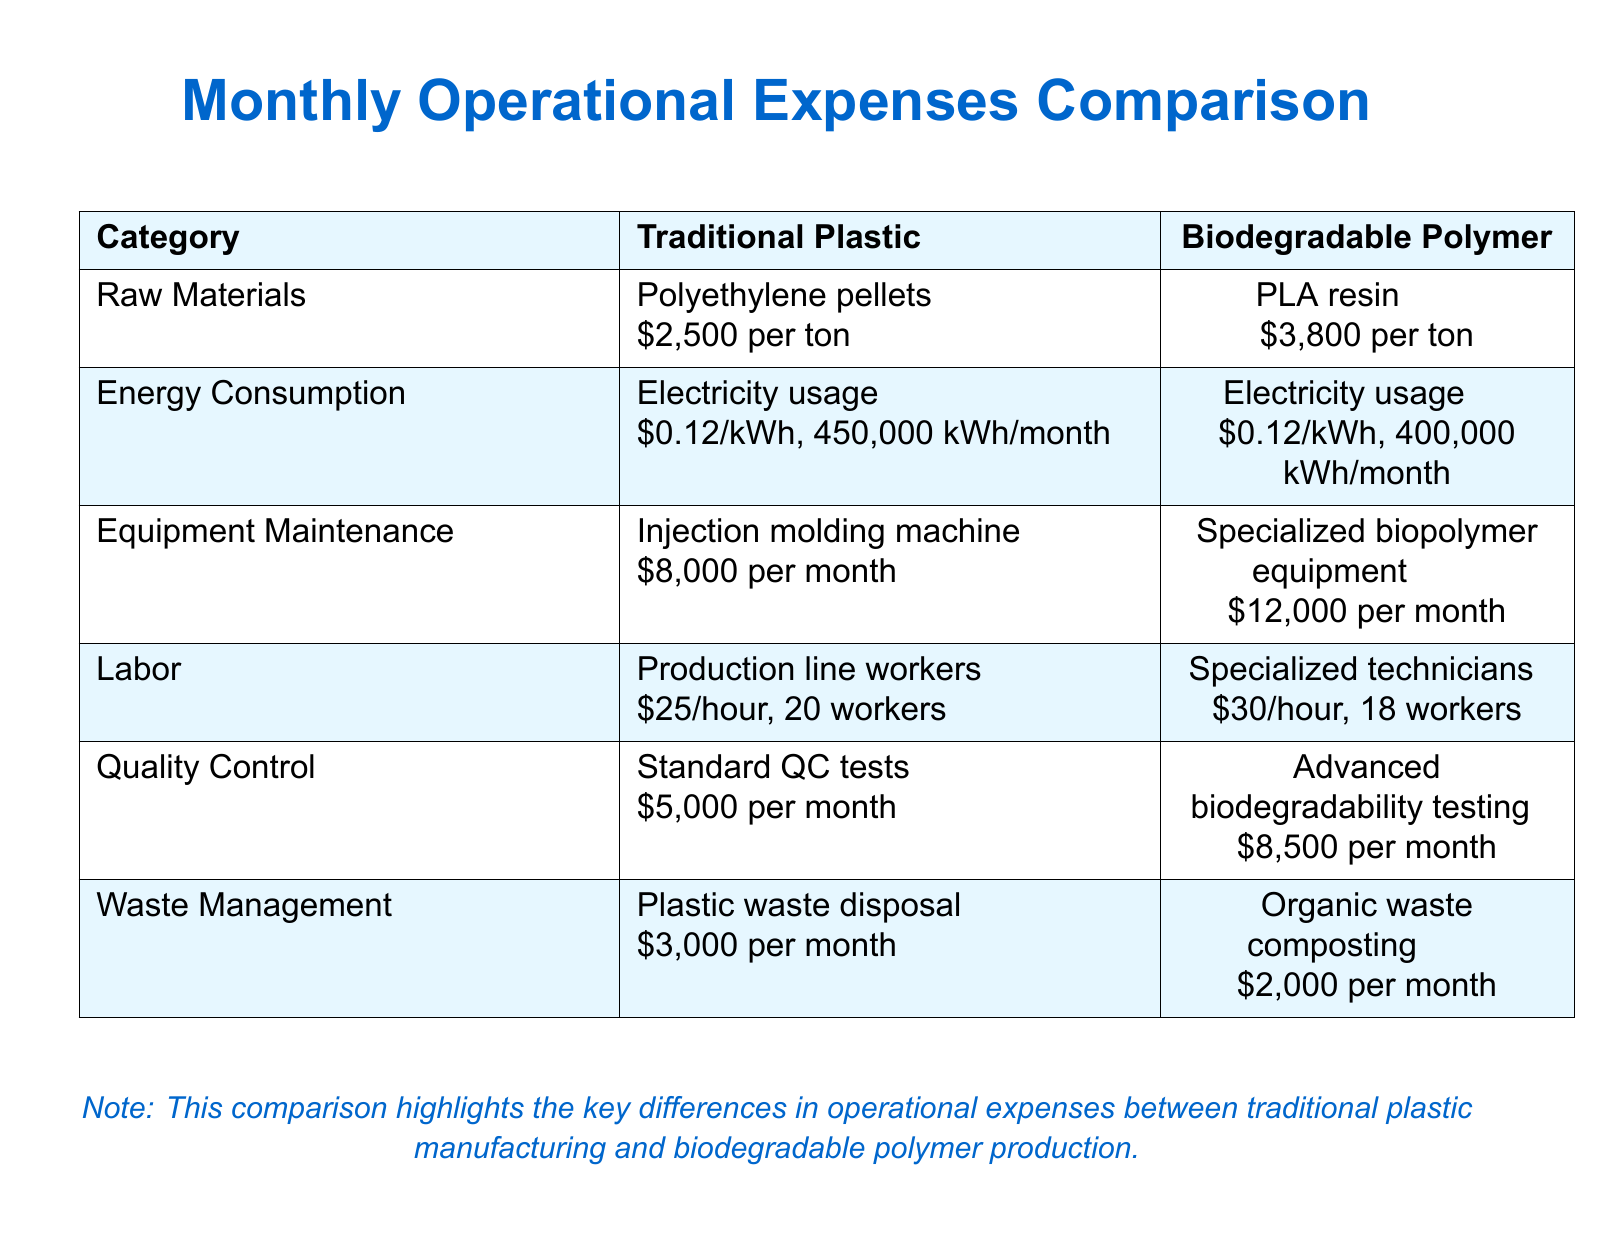What is the cost of raw materials for traditional plastic? The cost of raw materials for traditional plastic is provided in the document as $2,500 per ton for polyethylene pellets.
Answer: $2,500 per ton What is the energy consumption for biodegradable polymer production? The document states that the electricity usage for biodegradable polymer production is 400,000 kWh per month, at a rate of $0.12 per kWh.
Answer: 400,000 kWh per month How much does equipment maintenance cost for biodegradable polymer production? The document lists the equipment maintenance cost for biodegradable polymer equipment as $12,000 per month.
Answer: $12,000 per month What is the hourly wage for production line workers in traditional plastic manufacturing? According to the document, production line workers in traditional plastic manufacturing earn $25 per hour.
Answer: $25 per hour Which category has a lower cost in waste management? The document indicates that the cost for waste management is lower for biodegradable polymer production at $2,000 per month compared to traditional plastic which is $3,000 per month.
Answer: Organic waste composting What is the total labor cost for biodegradable polymer production when considering 18 technicians? Each specialized technician earns $30 per hour; thus, the total for one month (assuming full-time of 160 hours each) would be $30 x 18 x 160.
Answer: $86,400 Which manufacturing type incurs higher costs for quality control? The document shows that advanced biodegradability testing for biodegradable polymers costs $8,500 per month compared to $5,000 for standard quality control tests for traditional plastics.
Answer: Biodegradable polymer What is the difference in energy consumption costs between both production types? The energy consumption cost can be calculated based on kWh, where traditional plastic uses 450,000 kWh at $0.12/kWh and biodegradable uses 400,000 kWh at the same rate, leading to a difference.
Answer: $6,000 Overall, which production type has the highest total monthly operational expenses? When calculating the total monthly operational costs from the provided categories, the total for traditional plastic is higher than that of biodegradable polymer production.
Answer: Traditional plastic 